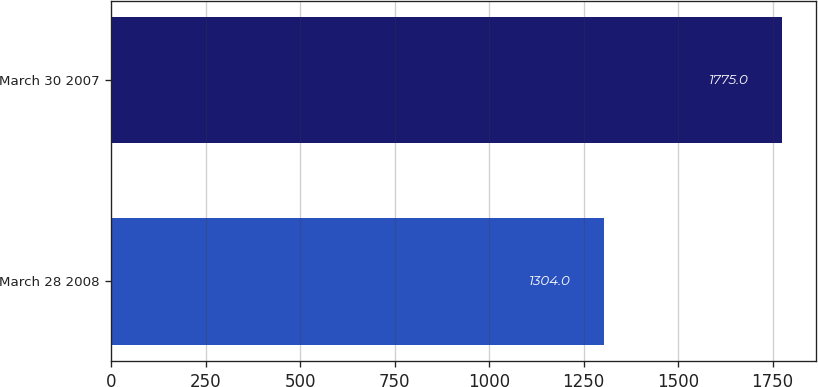Convert chart to OTSL. <chart><loc_0><loc_0><loc_500><loc_500><bar_chart><fcel>March 28 2008<fcel>March 30 2007<nl><fcel>1304<fcel>1775<nl></chart> 